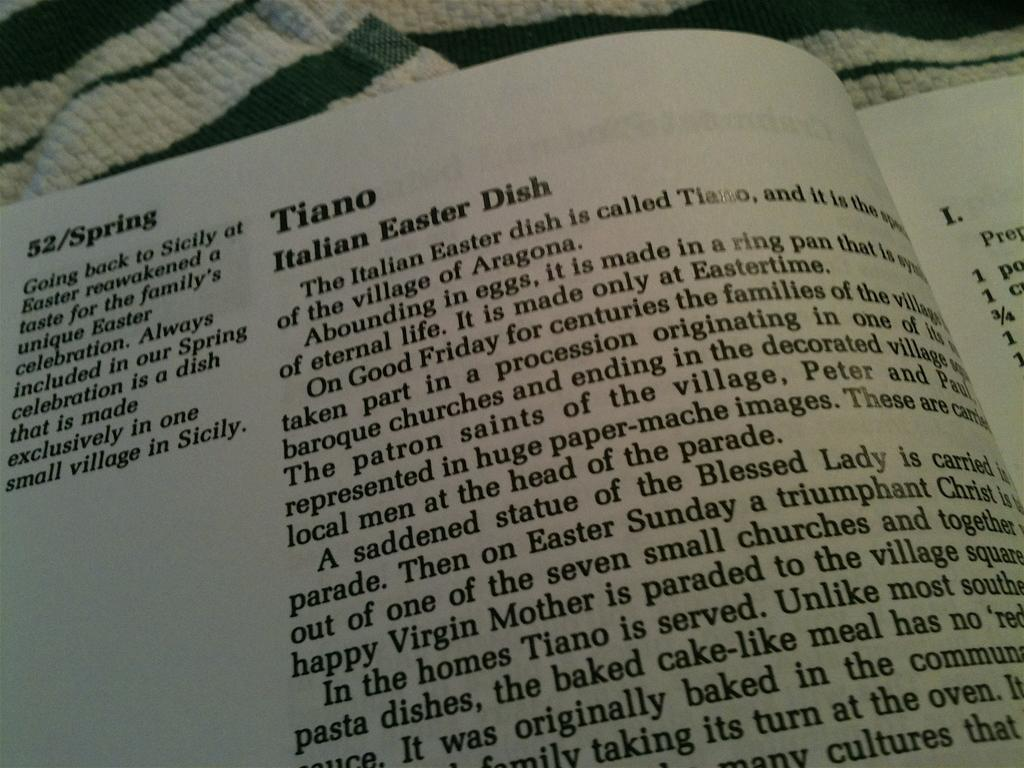Provide a one-sentence caption for the provided image. A page of a book describing an Italian Easter dish. 